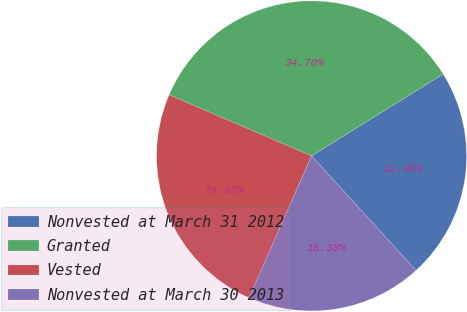<chart> <loc_0><loc_0><loc_500><loc_500><pie_chart><fcel>Nonvested at March 31 2012<fcel>Granted<fcel>Vested<fcel>Nonvested at March 30 2013<nl><fcel>22.09%<fcel>34.7%<fcel>24.83%<fcel>18.38%<nl></chart> 